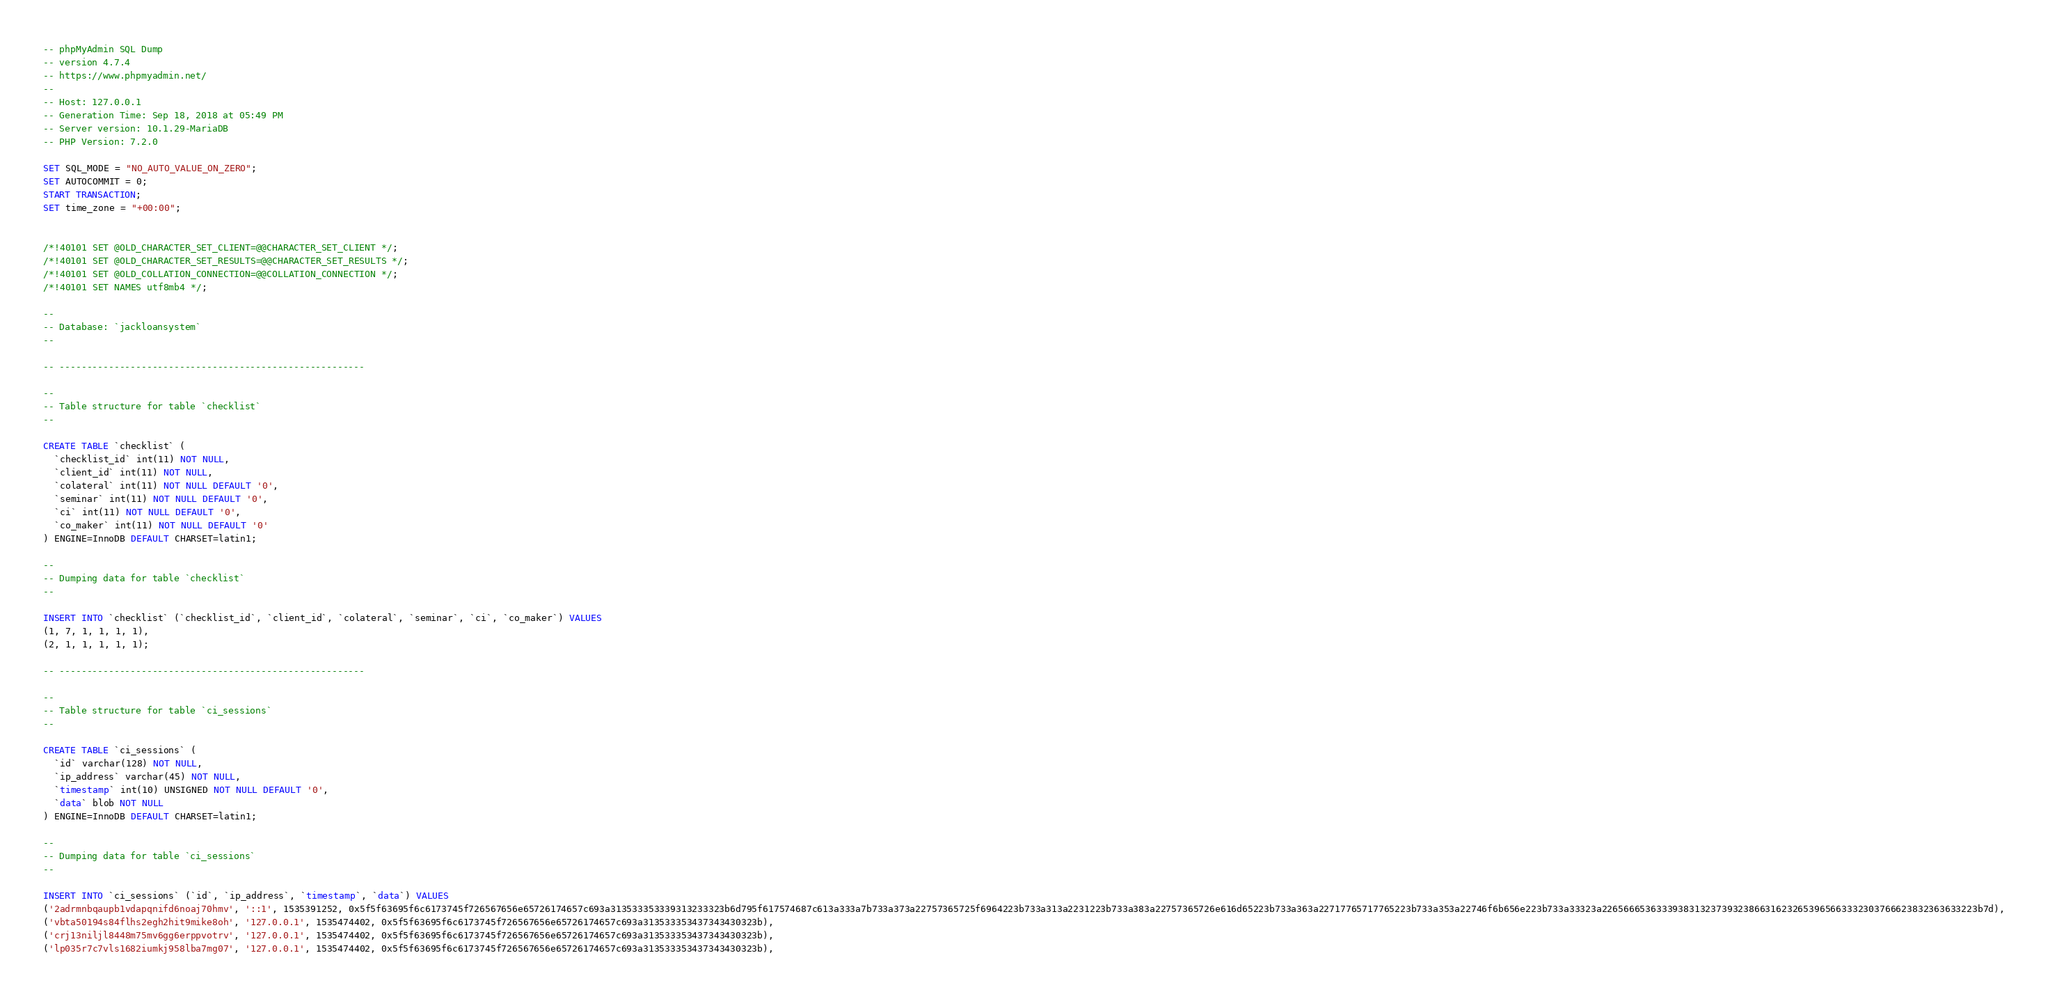Convert code to text. <code><loc_0><loc_0><loc_500><loc_500><_SQL_>-- phpMyAdmin SQL Dump
-- version 4.7.4
-- https://www.phpmyadmin.net/
--
-- Host: 127.0.0.1
-- Generation Time: Sep 18, 2018 at 05:49 PM
-- Server version: 10.1.29-MariaDB
-- PHP Version: 7.2.0

SET SQL_MODE = "NO_AUTO_VALUE_ON_ZERO";
SET AUTOCOMMIT = 0;
START TRANSACTION;
SET time_zone = "+00:00";


/*!40101 SET @OLD_CHARACTER_SET_CLIENT=@@CHARACTER_SET_CLIENT */;
/*!40101 SET @OLD_CHARACTER_SET_RESULTS=@@CHARACTER_SET_RESULTS */;
/*!40101 SET @OLD_COLLATION_CONNECTION=@@COLLATION_CONNECTION */;
/*!40101 SET NAMES utf8mb4 */;

--
-- Database: `jackloansystem`
--

-- --------------------------------------------------------

--
-- Table structure for table `checklist`
--

CREATE TABLE `checklist` (
  `checklist_id` int(11) NOT NULL,
  `client_id` int(11) NOT NULL,
  `colateral` int(11) NOT NULL DEFAULT '0',
  `seminar` int(11) NOT NULL DEFAULT '0',
  `ci` int(11) NOT NULL DEFAULT '0',
  `co_maker` int(11) NOT NULL DEFAULT '0'
) ENGINE=InnoDB DEFAULT CHARSET=latin1;

--
-- Dumping data for table `checklist`
--

INSERT INTO `checklist` (`checklist_id`, `client_id`, `colateral`, `seminar`, `ci`, `co_maker`) VALUES
(1, 7, 1, 1, 1, 1),
(2, 1, 1, 1, 1, 1);

-- --------------------------------------------------------

--
-- Table structure for table `ci_sessions`
--

CREATE TABLE `ci_sessions` (
  `id` varchar(128) NOT NULL,
  `ip_address` varchar(45) NOT NULL,
  `timestamp` int(10) UNSIGNED NOT NULL DEFAULT '0',
  `data` blob NOT NULL
) ENGINE=InnoDB DEFAULT CHARSET=latin1;

--
-- Dumping data for table `ci_sessions`
--

INSERT INTO `ci_sessions` (`id`, `ip_address`, `timestamp`, `data`) VALUES
('2adrmnbqaupb1vdapqnifd6noaj70hmv', '::1', 1535391252, 0x5f5f63695f6c6173745f726567656e65726174657c693a313533353339313233323b6d795f617574687c613a333a7b733a373a22757365725f6964223b733a313a2231223b733a383a22757365726e616d65223b733a363a22717765717765223b733a353a22746f6b656e223b733a33323a226566653633393831323739323866316232653965663332303766623832363633223b7d),
('vbta50194s84flhs2egh2hit9mike8oh', '127.0.0.1', 1535474402, 0x5f5f63695f6c6173745f726567656e65726174657c693a313533353437343430323b),
('crj13niljl8448m75mv6gg6erppvotrv', '127.0.0.1', 1535474402, 0x5f5f63695f6c6173745f726567656e65726174657c693a313533353437343430323b),
('lp035r7c7vls1682iumkj958lba7mg07', '127.0.0.1', 1535474402, 0x5f5f63695f6c6173745f726567656e65726174657c693a313533353437343430323b),</code> 